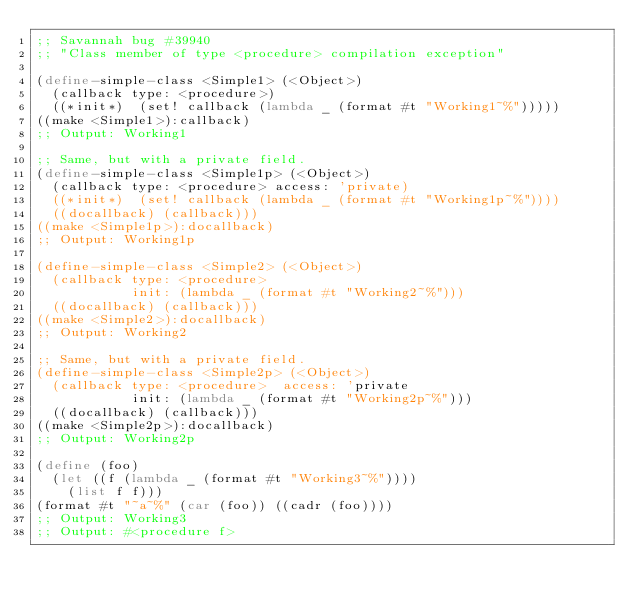<code> <loc_0><loc_0><loc_500><loc_500><_Scheme_>;; Savannah bug #39940
;; "Class member of type <procedure> compilation exception"

(define-simple-class <Simple1> (<Object>)
  (callback type: <procedure>)
  ((*init*)  (set! callback (lambda _ (format #t "Working1~%")))))
((make <Simple1>):callback)
;; Output: Working1

;; Same, but with a private field.
(define-simple-class <Simple1p> (<Object>)
  (callback type: <procedure> access: 'private)
  ((*init*)  (set! callback (lambda _ (format #t "Working1p~%"))))
  ((docallback) (callback)))
((make <Simple1p>):docallback)
;; Output: Working1p

(define-simple-class <Simple2> (<Object>)
  (callback type: <procedure>
            init: (lambda _ (format #t "Working2~%")))
  ((docallback) (callback)))
((make <Simple2>):docallback)
;; Output: Working2

;; Same, but with a private field.
(define-simple-class <Simple2p> (<Object>)
  (callback type: <procedure>  access: 'private
            init: (lambda _ (format #t "Working2p~%")))
  ((docallback) (callback)))
((make <Simple2p>):docallback)
;; Output: Working2p

(define (foo)
  (let ((f (lambda _ (format #t "Working3~%"))))
    (list f f)))
(format #t "~a~%" (car (foo)) ((cadr (foo))))
;; Output: Working3
;; Output: #<procedure f>
</code> 